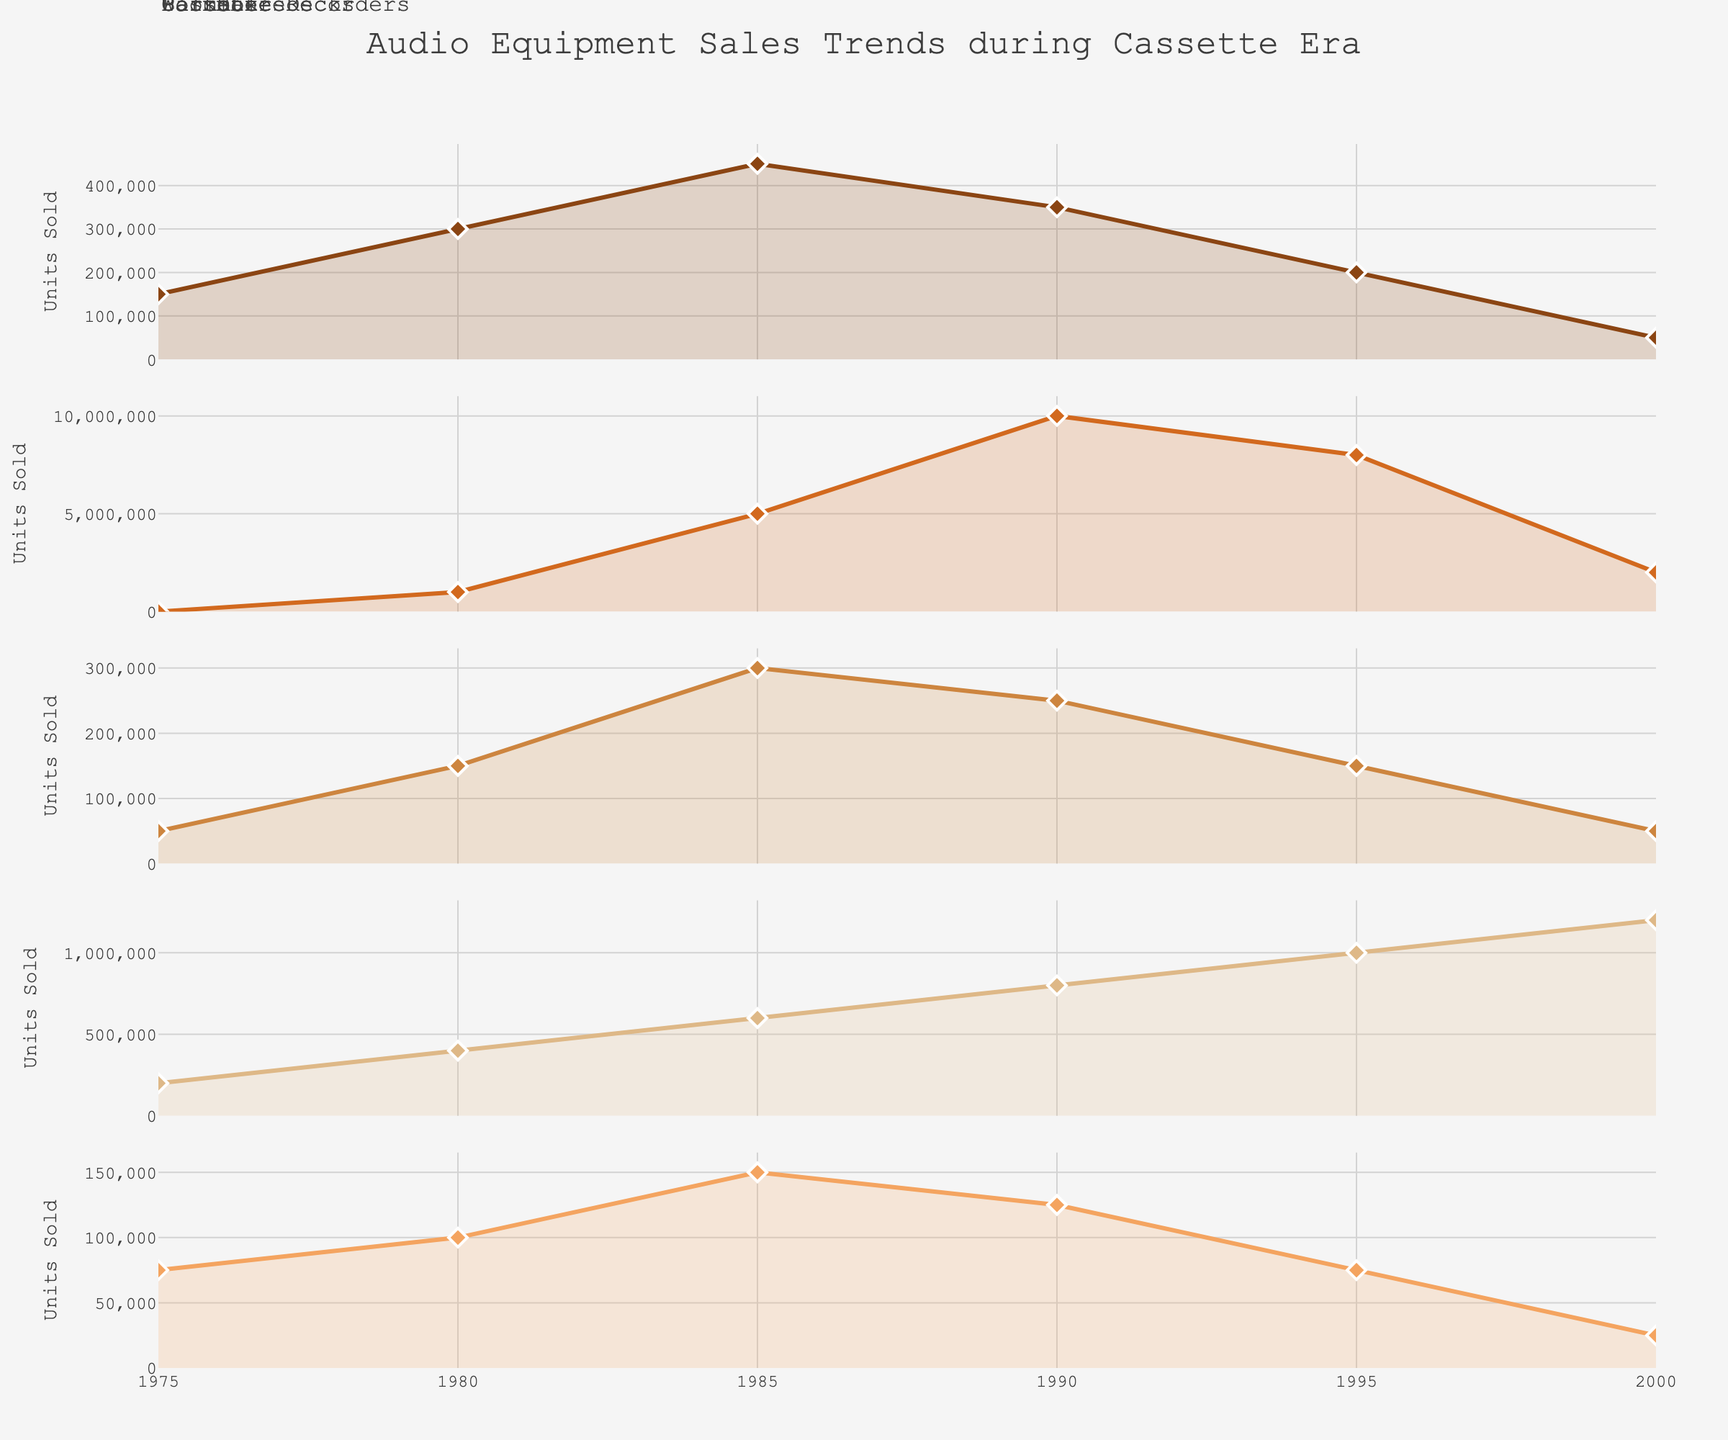What is the title of the figure? The title is usually positioned at the top center of the chart and is often larger or in a different font to make it stand out. The title of this figure is "Audio Equipment Sales Trends during Cassette Era".
Answer: Audio Equipment Sales Trends during Cassette Era What years does this data cover? The x-axis represents the years covered in the data. Looking at the values, it ranges from 1975 to 2000.
Answer: 1975-2000 Which device had the highest sales peak according to the subplots? To find the highest sales peak, compare the maximum points of each subplot. The Walkman show the highest peak with 10,000,000 units sold around 1990.
Answer: Walkman How did Cassette Deck sales change from 1985 to 1990? By examining the 'Cassette Decks' subplot, we can see that sales dropped from 450,000 units in 1985 to 350,000 units in 1990, a decrease of 100,000 units.
Answer: Decreased by 100,000 units What is the trend of Car Stereos sales over the years? Looking at the 'Car Stereos' subplot, there is a clear upward trend from 200,000 in 1975 to 1,200,000 in 2000, indicating a rising popularity over the years.
Answer: Upward trend By how much did Boombox sales decrease between their peak year and 2000? The peak for Boombox sales occurred in 1985 with 300,000 units sold, then decreased to 50,000 by 2000. The difference is 300,000 - 50,000 = 250,000 units.
Answer: 250,000 units Comparing Walkman and Portable Recorders, which had a more significant decline in sales after their peak year? The Walkman peaked at 10,000,000 units in 1990 and dropped to 2,000,000 by 2000, a decline of 8,000,000 units. Portable Recorders peaked at 150,000 in 1985 and dropped to 25,000 by 2000, a decline of 125,000 units. The Walkman had a more significant decline.
Answer: Walkman What is the general trend of Portable Recorders sales from 1975 to 2000? The 'Portable Recorders' subplot shows a decline from 75,000 units in 1975 to 25,000 units in 2000.
Answer: Downward trend Which device types show a clear peak followed by a decline in their sales trends? By examining the subplots, Walkman and Boomboxes both show a clear peak and subsequent decline in sales.
Answer: Walkman, Boomboxes 